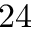<formula> <loc_0><loc_0><loc_500><loc_500>2 4</formula> 